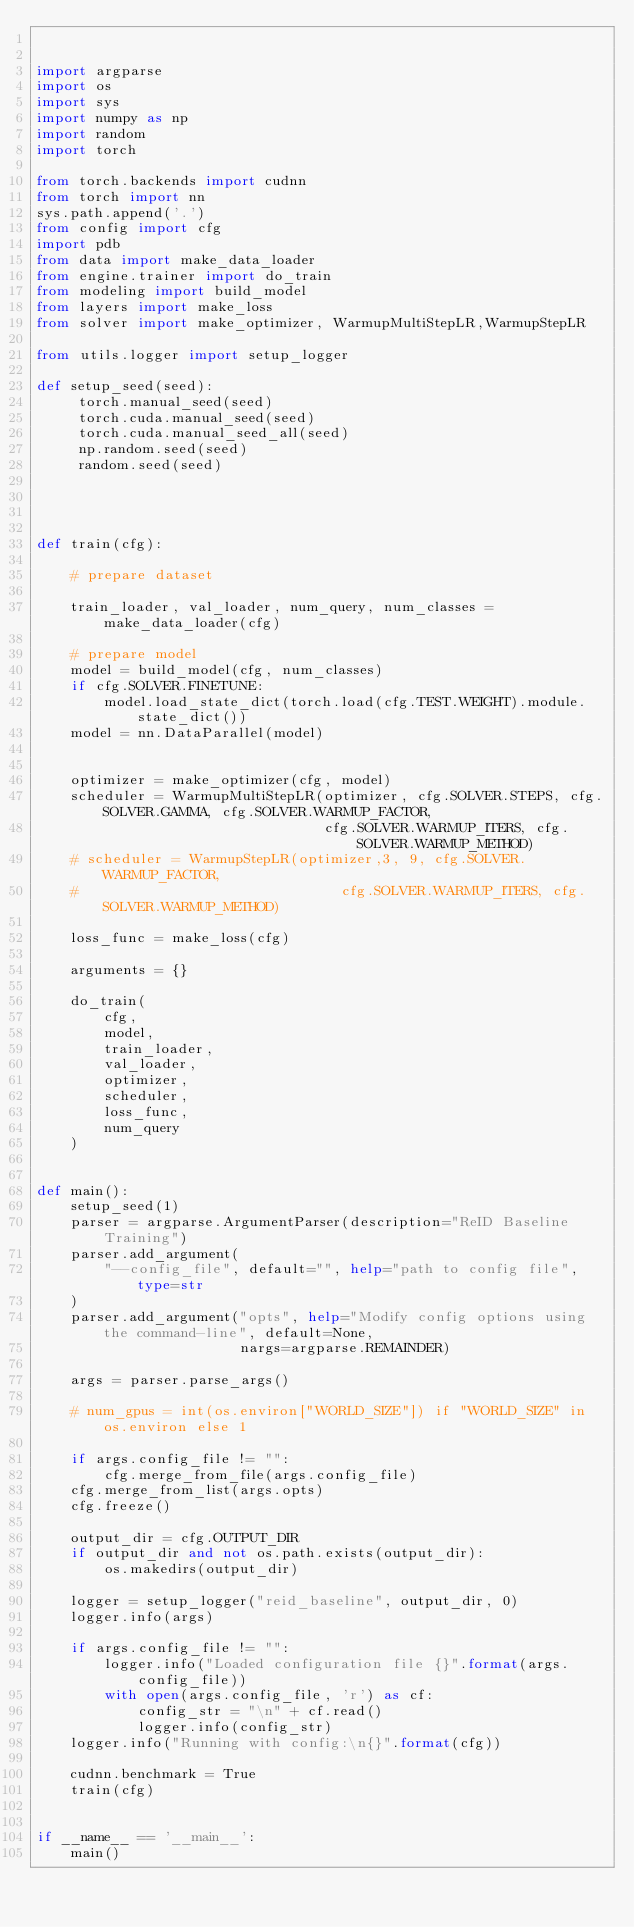Convert code to text. <code><loc_0><loc_0><loc_500><loc_500><_Python_>

import argparse
import os
import sys
import numpy as np
import random
import torch

from torch.backends import cudnn
from torch import nn
sys.path.append('.')
from config import cfg
import pdb
from data import make_data_loader
from engine.trainer import do_train
from modeling import build_model
from layers import make_loss
from solver import make_optimizer, WarmupMultiStepLR,WarmupStepLR

from utils.logger import setup_logger

def setup_seed(seed):
     torch.manual_seed(seed)
     torch.cuda.manual_seed(seed)
     torch.cuda.manual_seed_all(seed)
     np.random.seed(seed)
     random.seed(seed)




def train(cfg):
    
    # prepare dataset

    train_loader, val_loader, num_query, num_classes = make_data_loader(cfg)

    # prepare model
    model = build_model(cfg, num_classes)
    if cfg.SOLVER.FINETUNE:
        model.load_state_dict(torch.load(cfg.TEST.WEIGHT).module.state_dict())
    model = nn.DataParallel(model)


    optimizer = make_optimizer(cfg, model)
    scheduler = WarmupMultiStepLR(optimizer, cfg.SOLVER.STEPS, cfg.SOLVER.GAMMA, cfg.SOLVER.WARMUP_FACTOR,
                                  cfg.SOLVER.WARMUP_ITERS, cfg.SOLVER.WARMUP_METHOD)
    # scheduler = WarmupStepLR(optimizer,3, 9, cfg.SOLVER.WARMUP_FACTOR,
    #                               cfg.SOLVER.WARMUP_ITERS, cfg.SOLVER.WARMUP_METHOD)

    loss_func = make_loss(cfg)

    arguments = {}

    do_train(
        cfg,
        model,
        train_loader,
        val_loader,
        optimizer,
        scheduler,
        loss_func,
        num_query
    )


def main():
    setup_seed(1)
    parser = argparse.ArgumentParser(description="ReID Baseline Training")
    parser.add_argument(
        "--config_file", default="", help="path to config file", type=str
    )
    parser.add_argument("opts", help="Modify config options using the command-line", default=None,
                        nargs=argparse.REMAINDER)

    args = parser.parse_args()

    # num_gpus = int(os.environ["WORLD_SIZE"]) if "WORLD_SIZE" in os.environ else 1

    if args.config_file != "":
        cfg.merge_from_file(args.config_file)
    cfg.merge_from_list(args.opts)
    cfg.freeze()

    output_dir = cfg.OUTPUT_DIR
    if output_dir and not os.path.exists(output_dir):
        os.makedirs(output_dir)

    logger = setup_logger("reid_baseline", output_dir, 0)
    logger.info(args)

    if args.config_file != "":
        logger.info("Loaded configuration file {}".format(args.config_file))
        with open(args.config_file, 'r') as cf:
            config_str = "\n" + cf.read()
            logger.info(config_str)
    logger.info("Running with config:\n{}".format(cfg))

    cudnn.benchmark = True
    train(cfg)


if __name__ == '__main__':
    main()
</code> 